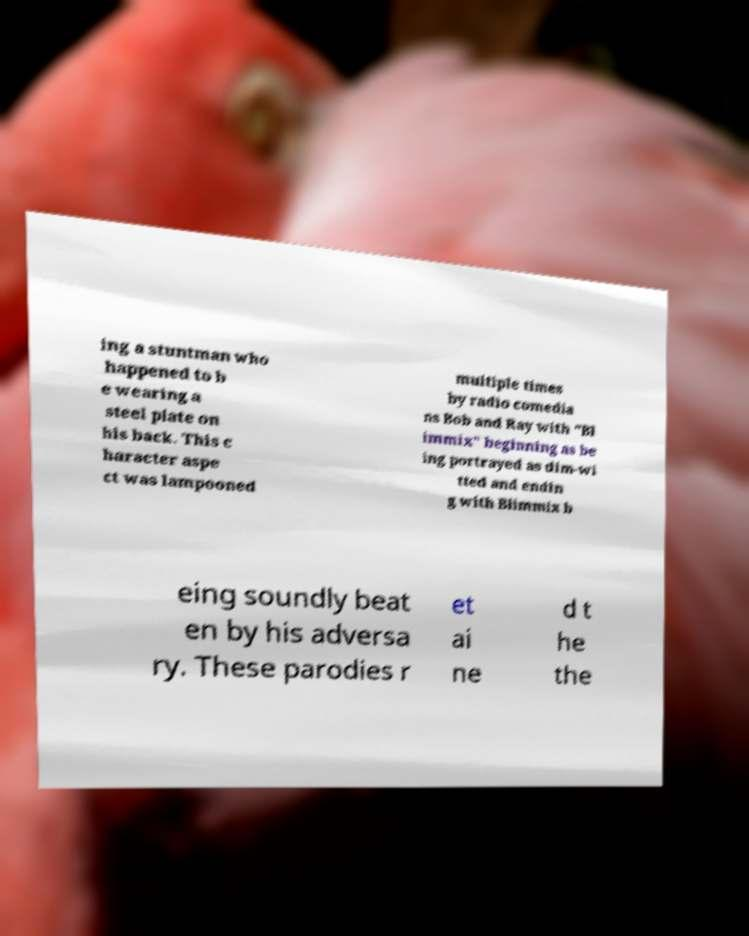Please read and relay the text visible in this image. What does it say? ing a stuntman who happened to b e wearing a steel plate on his back. This c haracter aspe ct was lampooned multiple times by radio comedia ns Bob and Ray with "Bl immix" beginning as be ing portrayed as dim-wi tted and endin g with Blimmix b eing soundly beat en by his adversa ry. These parodies r et ai ne d t he the 